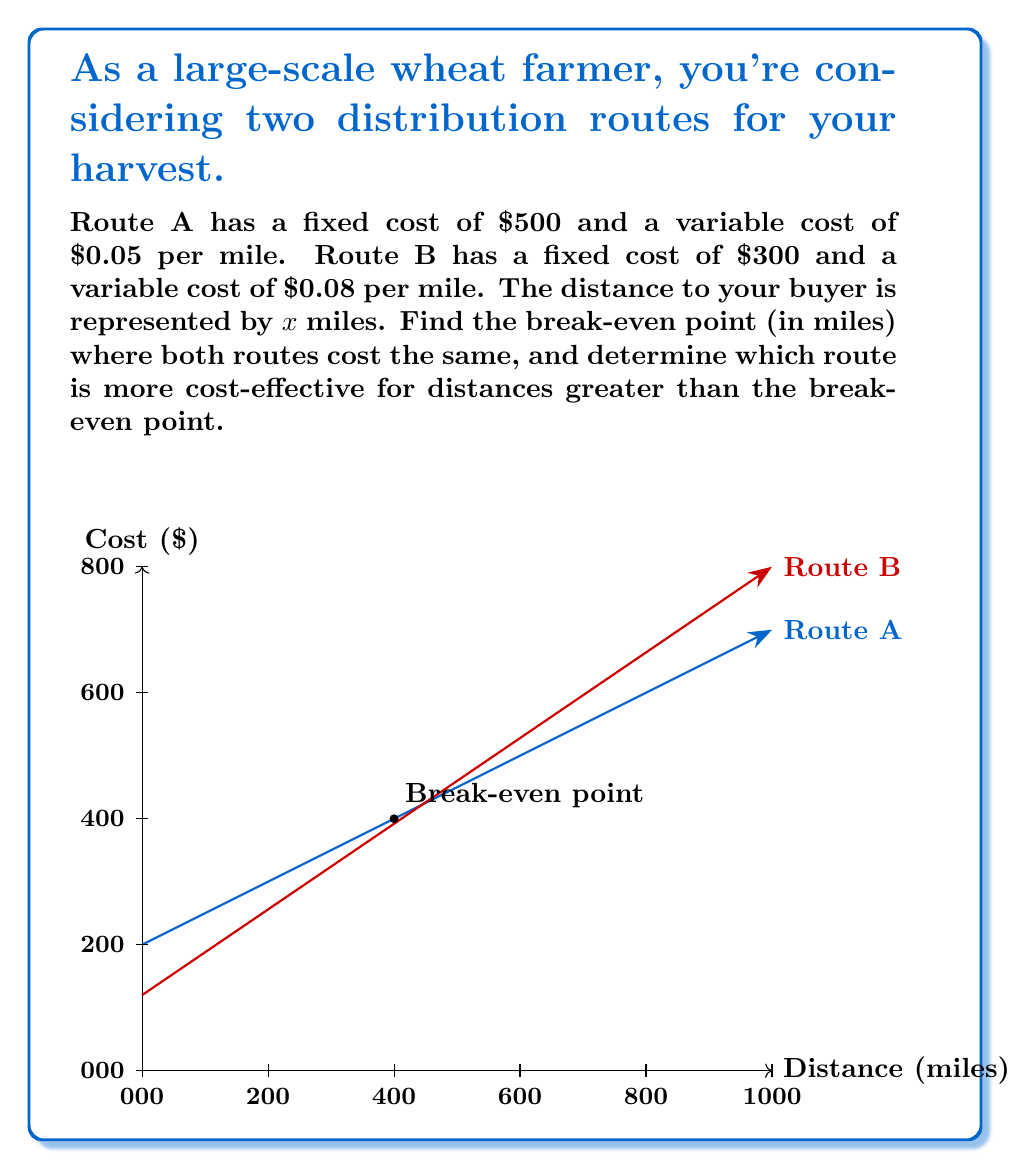Solve this math problem. Let's approach this step-by-step:

1) First, we need to set up equations for the total cost of each route:

   Route A: $y_A = 500 + 0.05x$
   Route B: $y_B = 300 + 0.08x$

   Where $y$ is the total cost and $x$ is the distance in miles.

2) To find the break-even point, we set these equations equal to each other:

   $500 + 0.05x = 300 + 0.08x$

3) Now, let's solve for $x$:

   $500 + 0.05x = 300 + 0.08x$
   $200 = 0.03x$
   $x = 200 / 0.03 = 6666.67$

4) Therefore, the break-even point is approximately 6,667 miles.

5) To determine which route is more cost-effective for distances greater than the break-even point, we can compare the slopes of the two equations:

   Route A: slope = 0.05
   Route B: slope = 0.08

   Since Route A has a smaller slope, it will be cheaper for distances greater than the break-even point.

6) We can verify this by calculating the cost for a distance slightly larger than the break-even point, say 7,000 miles:

   Route A: $500 + 0.05(7000) = 850$
   Route B: $300 + 0.08(7000) = 860$

   Indeed, Route A is cheaper for distances greater than the break-even point.
Answer: Break-even point: 6,667 miles. Route A is more cost-effective beyond this distance. 